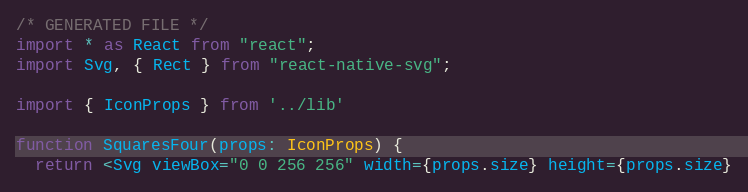Convert code to text. <code><loc_0><loc_0><loc_500><loc_500><_TypeScript_>/* GENERATED FILE */
import * as React from "react";
import Svg, { Rect } from "react-native-svg";

import { IconProps } from '../lib'

function SquaresFour(props: IconProps) {
  return <Svg viewBox="0 0 256 256" width={props.size} height={props.size}</code> 